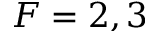<formula> <loc_0><loc_0><loc_500><loc_500>F = 2 , 3</formula> 